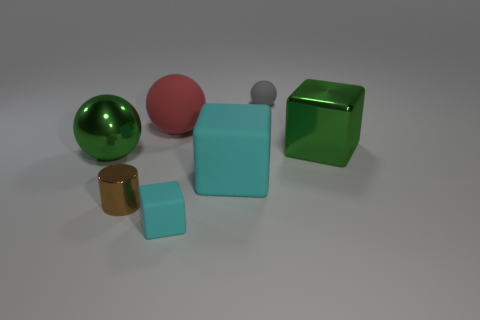What size is the cyan rubber object that is on the right side of the cyan rubber object that is in front of the brown metallic thing?
Offer a terse response. Large. Are there an equal number of big cyan objects in front of the tiny metallic cylinder and tiny rubber blocks that are behind the green cube?
Offer a very short reply. Yes. What is the color of the small matte thing that is the same shape as the large red thing?
Offer a terse response. Gray. What number of tiny objects are the same color as the small block?
Make the answer very short. 0. There is a big shiny object that is right of the big green shiny ball; is it the same shape as the gray object?
Keep it short and to the point. No. There is a green metallic thing that is to the right of the tiny matte thing that is to the right of the large matte object that is right of the big matte ball; what is its shape?
Make the answer very short. Cube. What is the size of the green cube?
Make the answer very short. Large. The big block that is made of the same material as the brown thing is what color?
Ensure brevity in your answer.  Green. How many small cyan blocks have the same material as the red object?
Give a very brief answer. 1. Does the metal cube have the same color as the large object that is in front of the large green sphere?
Your answer should be very brief. No. 